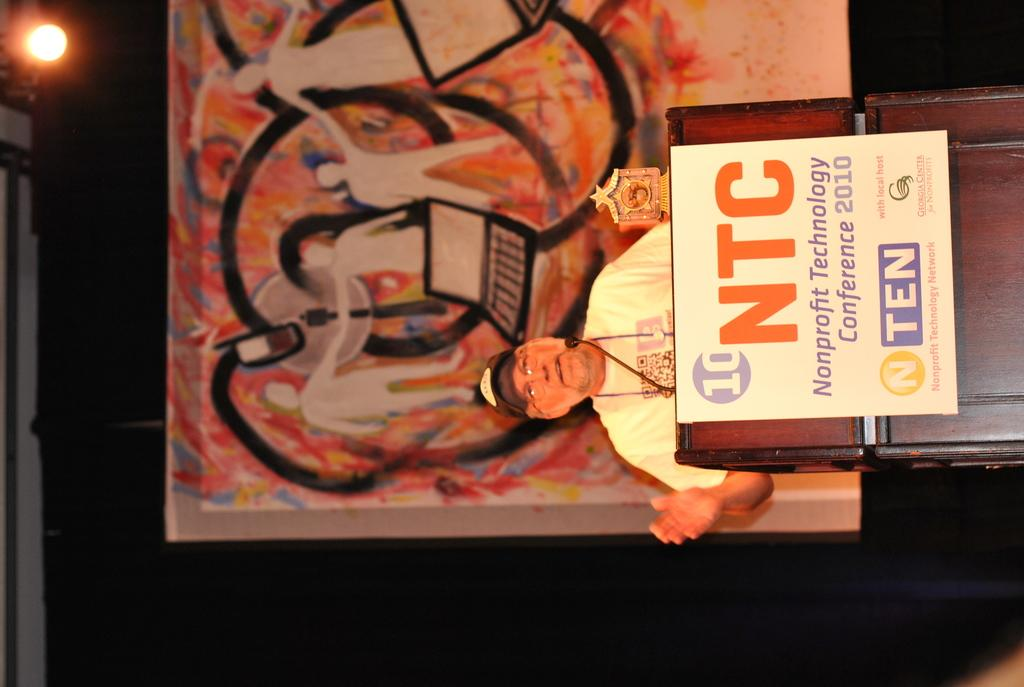What is the man in the image doing? The man is standing in front of a podium. What is the man wearing on his head? The man is wearing a cap. What is in front of the man for speaking? There is a microphone in front of the man. What is in front of the man for protection? There is a shield in front of the man. What can be seen in the background of the image? There is a light visible in the background. What is the queen doing with her brother in the image? There is no queen or brother present in the image; it features a man standing in front of a podium. What type of food is the cook preparing in the image? There is no cook or food preparation visible in the image. 